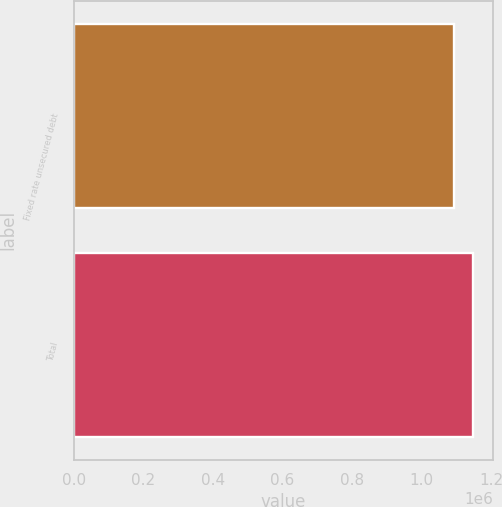Convert chart. <chart><loc_0><loc_0><loc_500><loc_500><bar_chart><fcel>Fixed rate unsecured debt<fcel>Total<nl><fcel>1.09458e+06<fcel>1.14802e+06<nl></chart> 